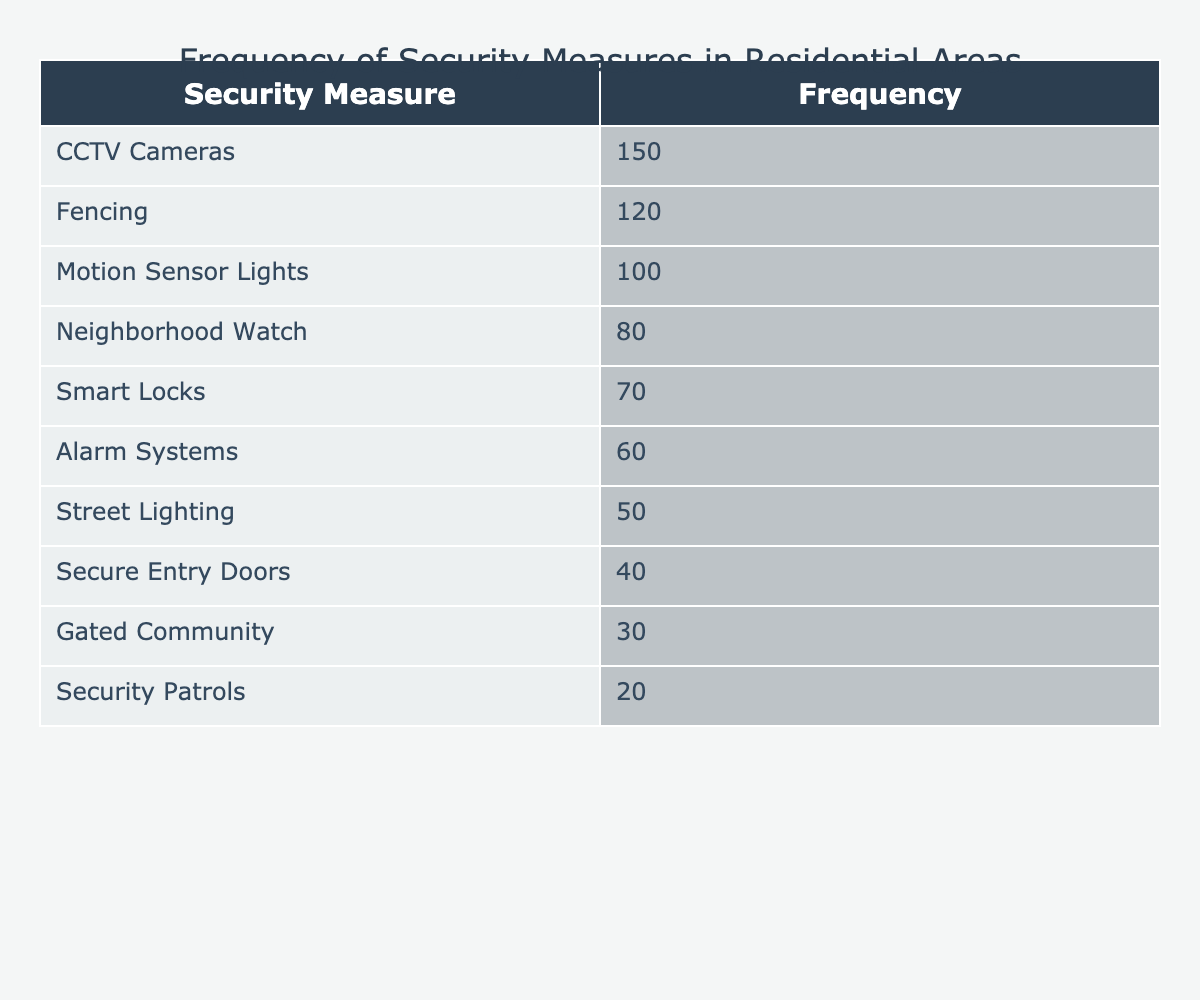What is the frequency of CCTV Cameras as a security measure? The table shows that CCTV Cameras have a frequency of 150, which indicates they are the most implemented security measure in residential areas.
Answer: 150 Which security measure has the least frequency? According to the table, the security measure with the least frequency is Security Patrols, with a frequency of 20.
Answer: Security Patrols What is the total frequency of the top three security measures? To find the total frequency of the top three security measures (CCTV Cameras, Fencing, Motion Sensor Lights), we add their frequencies: 150 + 120 + 100 = 370.
Answer: 370 Is Smart Locks more frequently implemented than Security Patrols? The frequency of Smart Locks is 70, while Security Patrols have a frequency of 20. Since 70 is greater than 20, the statement is true.
Answer: Yes What is the difference in frequency between Neighborhood Watch and Alarm Systems? Neighborhood Watch frequency is 80, and Alarm Systems frequency is 60. The difference is calculated as 80 - 60 = 20, meaning Neighborhood Watch is implemented 20 times more than Alarm Systems.
Answer: 20 What is the average frequency of all the security measures listed? To find the average frequency, first sum all the frequencies: 150 + 120 + 100 + 80 + 70 + 60 + 50 + 40 + 30 + 20 = 820. There are 10 different security measures, so the average is 820 / 10 = 82.
Answer: 82 How many security measures have a frequency greater than 60? The measures with a frequency greater than 60 are CCTV Cameras (150), Fencing (120), Motion Sensor Lights (100), and Smart Locks (70), totaling four measures exceeding 60.
Answer: 4 If we consider only the measures with a frequency of 50 or less, which ones are there? The measures with a frequency of 50 or less are Street Lighting (50), Secure Entry Doors (40), Gated Community (30), and Security Patrols (20). This gives us four measures.
Answer: 4 What is the combined frequency of Fencing and Gated Community? Fencing has a frequency of 120 and Gated Community has a frequency of 30. Adding these frequencies gives us 120 + 30 = 150.
Answer: 150 